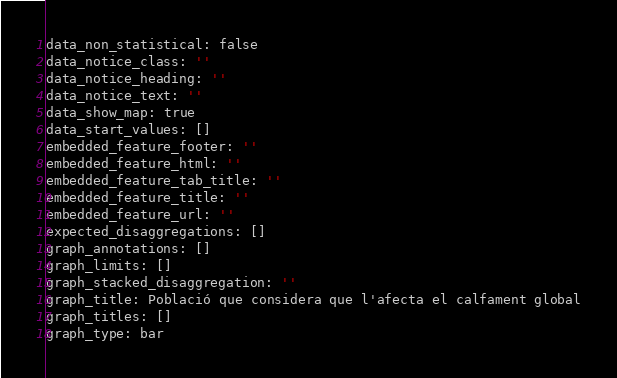<code> <loc_0><loc_0><loc_500><loc_500><_YAML_>data_non_statistical: false
data_notice_class: ''
data_notice_heading: ''
data_notice_text: ''
data_show_map: true
data_start_values: []
embedded_feature_footer: ''
embedded_feature_html: ''
embedded_feature_tab_title: ''
embedded_feature_title: ''
embedded_feature_url: ''
expected_disaggregations: []
graph_annotations: []
graph_limits: []
graph_stacked_disaggregation: ''
graph_title: Població que considera que l'afecta el calfament global
graph_titles: []
graph_type: bar</code> 